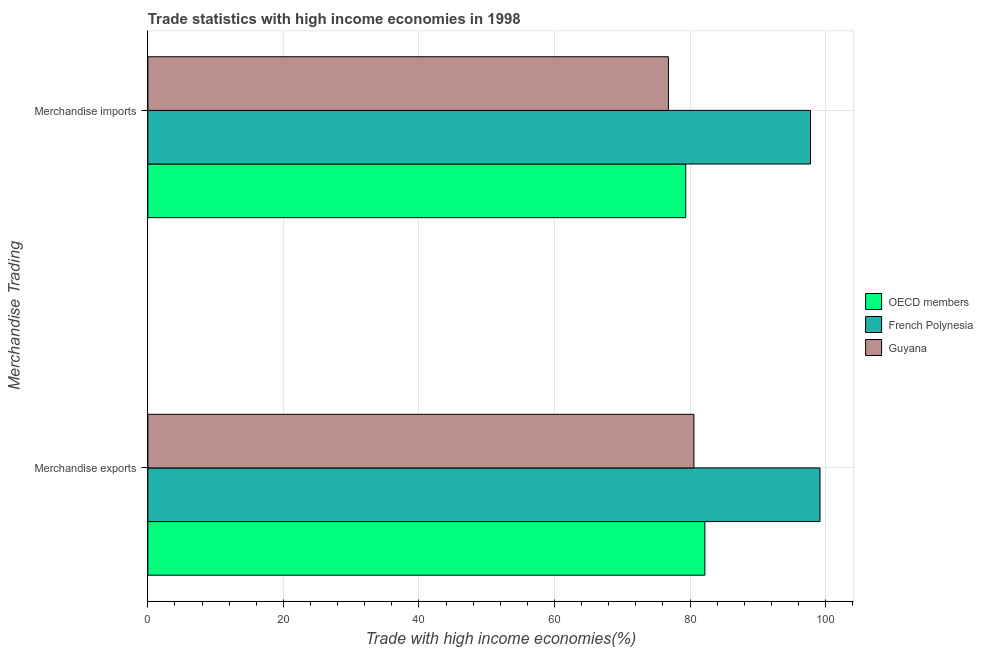How many groups of bars are there?
Provide a short and direct response. 2. Are the number of bars per tick equal to the number of legend labels?
Offer a very short reply. Yes. How many bars are there on the 1st tick from the bottom?
Keep it short and to the point. 3. What is the merchandise exports in OECD members?
Make the answer very short. 82.2. Across all countries, what is the maximum merchandise imports?
Your answer should be compact. 97.78. Across all countries, what is the minimum merchandise exports?
Your answer should be compact. 80.58. In which country was the merchandise exports maximum?
Keep it short and to the point. French Polynesia. In which country was the merchandise exports minimum?
Keep it short and to the point. Guyana. What is the total merchandise exports in the graph?
Provide a short and direct response. 261.95. What is the difference between the merchandise exports in Guyana and that in OECD members?
Provide a succinct answer. -1.62. What is the difference between the merchandise exports in Guyana and the merchandise imports in French Polynesia?
Your response must be concise. -17.21. What is the average merchandise imports per country?
Provide a short and direct response. 84.65. What is the difference between the merchandise imports and merchandise exports in OECD members?
Offer a terse response. -2.83. In how many countries, is the merchandise exports greater than 80 %?
Ensure brevity in your answer.  3. What is the ratio of the merchandise exports in Guyana to that in OECD members?
Your answer should be very brief. 0.98. What does the 2nd bar from the top in Merchandise imports represents?
Your answer should be very brief. French Polynesia. What does the 3rd bar from the bottom in Merchandise imports represents?
Ensure brevity in your answer.  Guyana. Are all the bars in the graph horizontal?
Ensure brevity in your answer.  Yes. How many countries are there in the graph?
Your answer should be compact. 3. Does the graph contain any zero values?
Your answer should be very brief. No. Does the graph contain grids?
Your answer should be very brief. Yes. How many legend labels are there?
Give a very brief answer. 3. What is the title of the graph?
Give a very brief answer. Trade statistics with high income economies in 1998. What is the label or title of the X-axis?
Your answer should be very brief. Trade with high income economies(%). What is the label or title of the Y-axis?
Your answer should be compact. Merchandise Trading. What is the Trade with high income economies(%) of OECD members in Merchandise exports?
Make the answer very short. 82.2. What is the Trade with high income economies(%) in French Polynesia in Merchandise exports?
Ensure brevity in your answer.  99.18. What is the Trade with high income economies(%) in Guyana in Merchandise exports?
Ensure brevity in your answer.  80.58. What is the Trade with high income economies(%) in OECD members in Merchandise imports?
Give a very brief answer. 79.37. What is the Trade with high income economies(%) in French Polynesia in Merchandise imports?
Offer a very short reply. 97.78. What is the Trade with high income economies(%) in Guyana in Merchandise imports?
Offer a very short reply. 76.81. Across all Merchandise Trading, what is the maximum Trade with high income economies(%) of OECD members?
Make the answer very short. 82.2. Across all Merchandise Trading, what is the maximum Trade with high income economies(%) of French Polynesia?
Provide a succinct answer. 99.18. Across all Merchandise Trading, what is the maximum Trade with high income economies(%) of Guyana?
Your answer should be compact. 80.58. Across all Merchandise Trading, what is the minimum Trade with high income economies(%) of OECD members?
Your response must be concise. 79.37. Across all Merchandise Trading, what is the minimum Trade with high income economies(%) in French Polynesia?
Your answer should be very brief. 97.78. Across all Merchandise Trading, what is the minimum Trade with high income economies(%) in Guyana?
Give a very brief answer. 76.81. What is the total Trade with high income economies(%) in OECD members in the graph?
Your answer should be very brief. 161.56. What is the total Trade with high income economies(%) of French Polynesia in the graph?
Make the answer very short. 196.96. What is the total Trade with high income economies(%) of Guyana in the graph?
Provide a short and direct response. 157.39. What is the difference between the Trade with high income economies(%) in OECD members in Merchandise exports and that in Merchandise imports?
Ensure brevity in your answer.  2.83. What is the difference between the Trade with high income economies(%) of French Polynesia in Merchandise exports and that in Merchandise imports?
Give a very brief answer. 1.4. What is the difference between the Trade with high income economies(%) in Guyana in Merchandise exports and that in Merchandise imports?
Provide a short and direct response. 3.77. What is the difference between the Trade with high income economies(%) in OECD members in Merchandise exports and the Trade with high income economies(%) in French Polynesia in Merchandise imports?
Keep it short and to the point. -15.59. What is the difference between the Trade with high income economies(%) of OECD members in Merchandise exports and the Trade with high income economies(%) of Guyana in Merchandise imports?
Offer a terse response. 5.38. What is the difference between the Trade with high income economies(%) in French Polynesia in Merchandise exports and the Trade with high income economies(%) in Guyana in Merchandise imports?
Your answer should be very brief. 22.37. What is the average Trade with high income economies(%) in OECD members per Merchandise Trading?
Offer a very short reply. 80.78. What is the average Trade with high income economies(%) in French Polynesia per Merchandise Trading?
Ensure brevity in your answer.  98.48. What is the average Trade with high income economies(%) in Guyana per Merchandise Trading?
Offer a terse response. 78.69. What is the difference between the Trade with high income economies(%) of OECD members and Trade with high income economies(%) of French Polynesia in Merchandise exports?
Your response must be concise. -16.98. What is the difference between the Trade with high income economies(%) of OECD members and Trade with high income economies(%) of Guyana in Merchandise exports?
Offer a very short reply. 1.62. What is the difference between the Trade with high income economies(%) in French Polynesia and Trade with high income economies(%) in Guyana in Merchandise exports?
Your answer should be very brief. 18.6. What is the difference between the Trade with high income economies(%) in OECD members and Trade with high income economies(%) in French Polynesia in Merchandise imports?
Offer a terse response. -18.42. What is the difference between the Trade with high income economies(%) of OECD members and Trade with high income economies(%) of Guyana in Merchandise imports?
Your answer should be very brief. 2.55. What is the difference between the Trade with high income economies(%) of French Polynesia and Trade with high income economies(%) of Guyana in Merchandise imports?
Offer a terse response. 20.97. What is the ratio of the Trade with high income economies(%) of OECD members in Merchandise exports to that in Merchandise imports?
Keep it short and to the point. 1.04. What is the ratio of the Trade with high income economies(%) of French Polynesia in Merchandise exports to that in Merchandise imports?
Provide a succinct answer. 1.01. What is the ratio of the Trade with high income economies(%) of Guyana in Merchandise exports to that in Merchandise imports?
Provide a short and direct response. 1.05. What is the difference between the highest and the second highest Trade with high income economies(%) of OECD members?
Offer a terse response. 2.83. What is the difference between the highest and the second highest Trade with high income economies(%) of French Polynesia?
Offer a terse response. 1.4. What is the difference between the highest and the second highest Trade with high income economies(%) of Guyana?
Offer a very short reply. 3.77. What is the difference between the highest and the lowest Trade with high income economies(%) in OECD members?
Offer a very short reply. 2.83. What is the difference between the highest and the lowest Trade with high income economies(%) in French Polynesia?
Your response must be concise. 1.4. What is the difference between the highest and the lowest Trade with high income economies(%) of Guyana?
Your answer should be very brief. 3.77. 